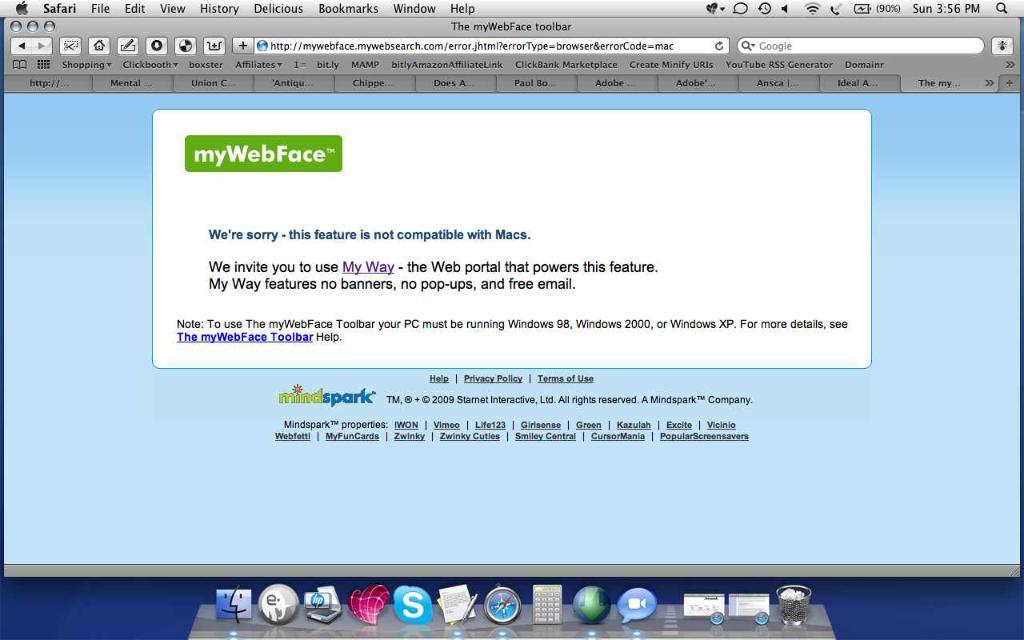What brand of computer is being used?
Your answer should be compact. Apple. 